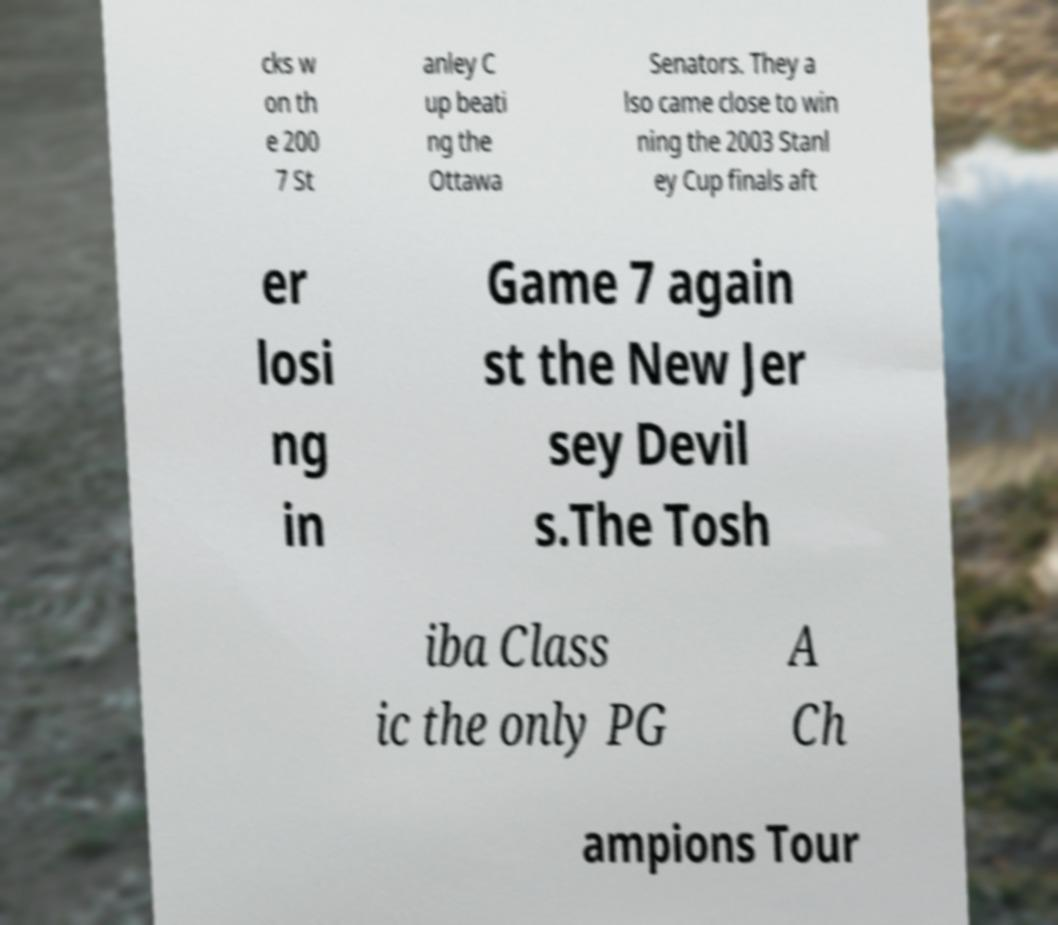Could you assist in decoding the text presented in this image and type it out clearly? cks w on th e 200 7 St anley C up beati ng the Ottawa Senators. They a lso came close to win ning the 2003 Stanl ey Cup finals aft er losi ng in Game 7 again st the New Jer sey Devil s.The Tosh iba Class ic the only PG A Ch ampions Tour 